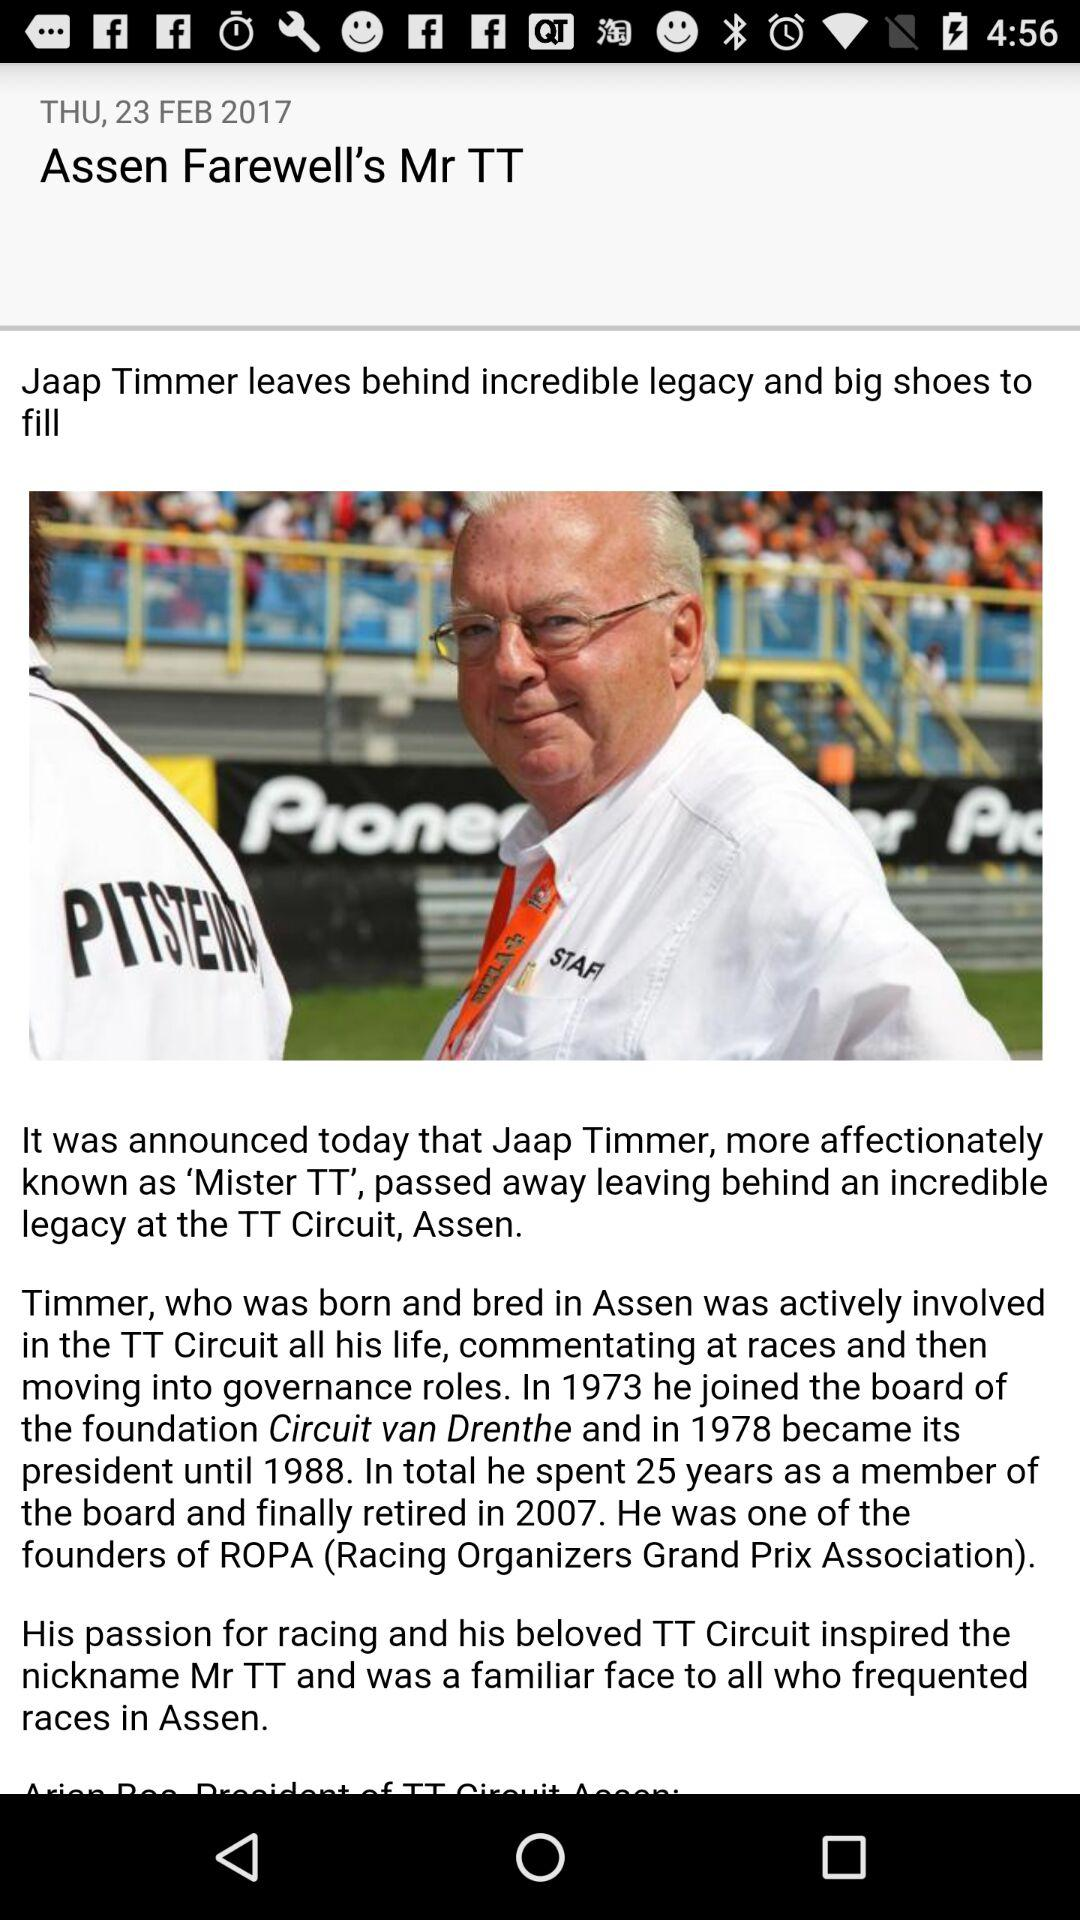What is the day on February 23,2017? The day is Thursday. 